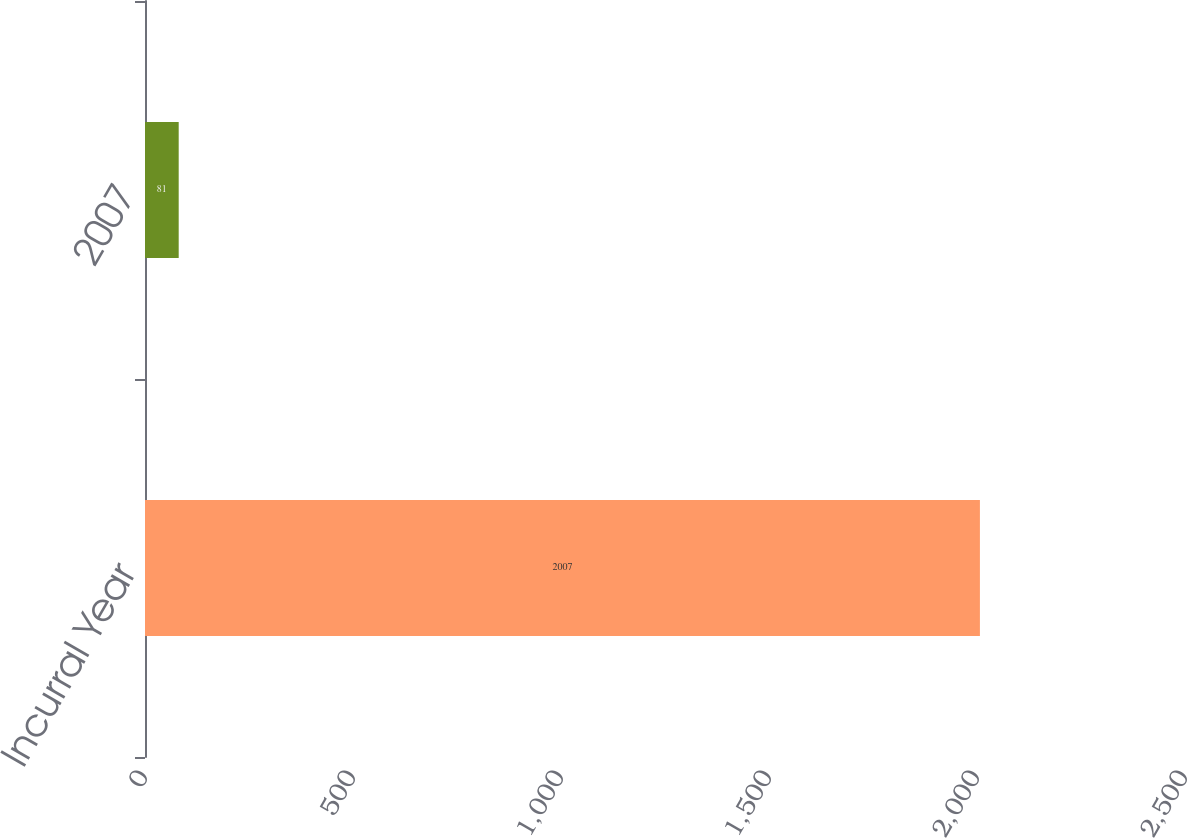Convert chart to OTSL. <chart><loc_0><loc_0><loc_500><loc_500><bar_chart><fcel>Incurral Year<fcel>2007<nl><fcel>2007<fcel>81<nl></chart> 